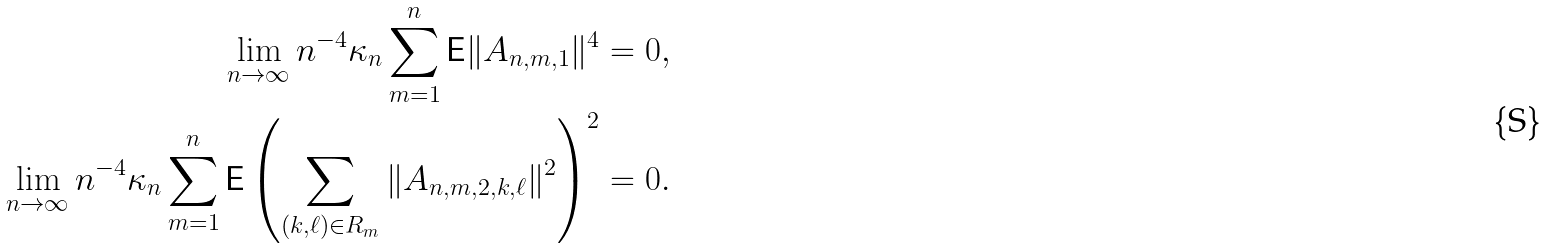Convert formula to latex. <formula><loc_0><loc_0><loc_500><loc_500>\lim _ { n \to \infty } n ^ { - 4 } \kappa _ { n } \sum _ { m = 1 } ^ { n } { \mathsf E } \| A _ { n , m , 1 } \| ^ { 4 } & = 0 , \\ \lim _ { n \to \infty } n ^ { - 4 } \kappa _ { n } \sum _ { m = 1 } ^ { n } { \mathsf E } \left ( \sum _ { ( k , \ell ) \in R _ { m } } \| A _ { n , m , 2 , k , \ell } \| ^ { 2 } \right ) ^ { 2 } & = 0 .</formula> 